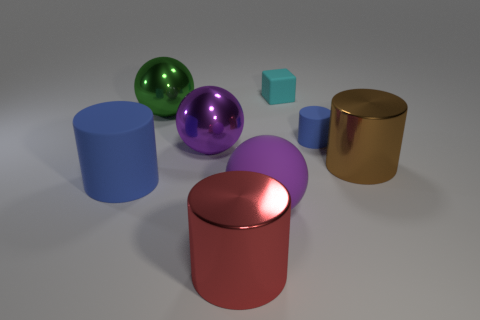Subtract all large blue matte cylinders. How many cylinders are left? 3 Subtract all brown cylinders. How many cylinders are left? 3 Subtract all blocks. How many objects are left? 7 Subtract 3 cylinders. How many cylinders are left? 1 Add 1 large cyan metallic cylinders. How many objects exist? 9 Subtract all small yellow balls. Subtract all purple matte things. How many objects are left? 7 Add 2 matte objects. How many matte objects are left? 6 Add 8 red metallic cylinders. How many red metallic cylinders exist? 9 Subtract 1 green spheres. How many objects are left? 7 Subtract all cyan cylinders. Subtract all purple blocks. How many cylinders are left? 4 